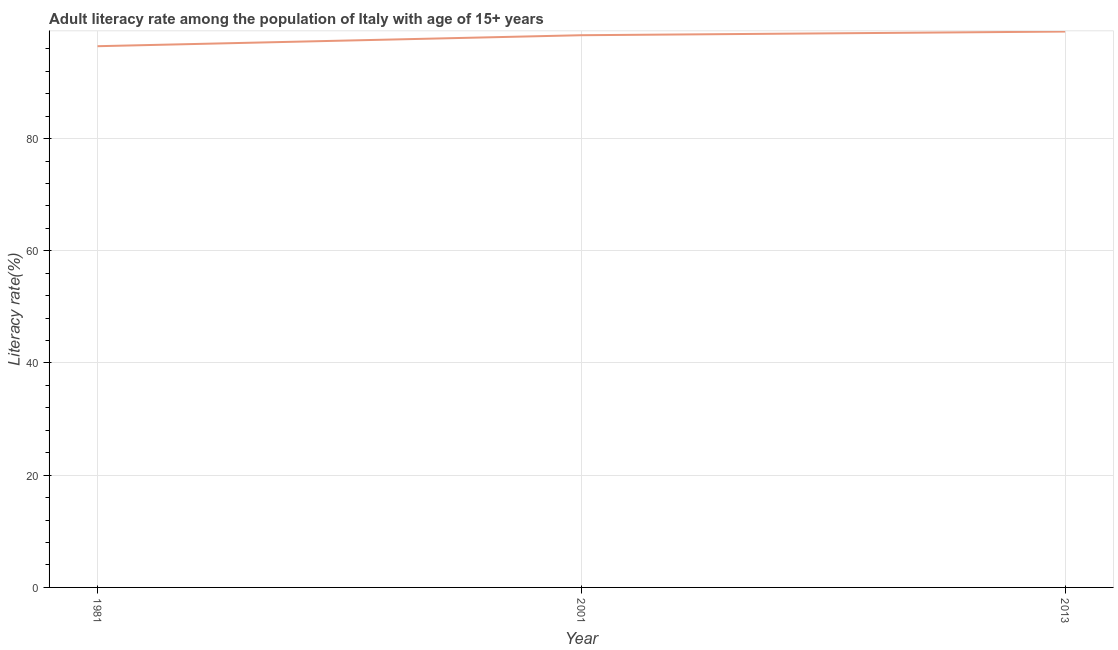What is the adult literacy rate in 1981?
Provide a succinct answer. 96.46. Across all years, what is the maximum adult literacy rate?
Offer a very short reply. 99.07. Across all years, what is the minimum adult literacy rate?
Your answer should be very brief. 96.46. In which year was the adult literacy rate maximum?
Your response must be concise. 2013. In which year was the adult literacy rate minimum?
Your response must be concise. 1981. What is the sum of the adult literacy rate?
Your response must be concise. 293.95. What is the difference between the adult literacy rate in 2001 and 2013?
Your answer should be very brief. -0.65. What is the average adult literacy rate per year?
Offer a very short reply. 97.98. What is the median adult literacy rate?
Provide a succinct answer. 98.42. What is the ratio of the adult literacy rate in 1981 to that in 2001?
Your answer should be compact. 0.98. Is the difference between the adult literacy rate in 2001 and 2013 greater than the difference between any two years?
Your answer should be compact. No. What is the difference between the highest and the second highest adult literacy rate?
Keep it short and to the point. 0.65. Is the sum of the adult literacy rate in 1981 and 2013 greater than the maximum adult literacy rate across all years?
Your answer should be very brief. Yes. What is the difference between the highest and the lowest adult literacy rate?
Provide a succinct answer. 2.61. How many lines are there?
Make the answer very short. 1. How many years are there in the graph?
Your answer should be compact. 3. What is the difference between two consecutive major ticks on the Y-axis?
Provide a succinct answer. 20. Does the graph contain any zero values?
Keep it short and to the point. No. Does the graph contain grids?
Offer a terse response. Yes. What is the title of the graph?
Offer a very short reply. Adult literacy rate among the population of Italy with age of 15+ years. What is the label or title of the X-axis?
Give a very brief answer. Year. What is the label or title of the Y-axis?
Provide a short and direct response. Literacy rate(%). What is the Literacy rate(%) in 1981?
Offer a terse response. 96.46. What is the Literacy rate(%) of 2001?
Provide a short and direct response. 98.42. What is the Literacy rate(%) of 2013?
Provide a succinct answer. 99.07. What is the difference between the Literacy rate(%) in 1981 and 2001?
Your answer should be very brief. -1.96. What is the difference between the Literacy rate(%) in 1981 and 2013?
Your answer should be very brief. -2.61. What is the difference between the Literacy rate(%) in 2001 and 2013?
Provide a succinct answer. -0.65. What is the ratio of the Literacy rate(%) in 1981 to that in 2001?
Your answer should be compact. 0.98. What is the ratio of the Literacy rate(%) in 1981 to that in 2013?
Your answer should be very brief. 0.97. What is the ratio of the Literacy rate(%) in 2001 to that in 2013?
Give a very brief answer. 0.99. 